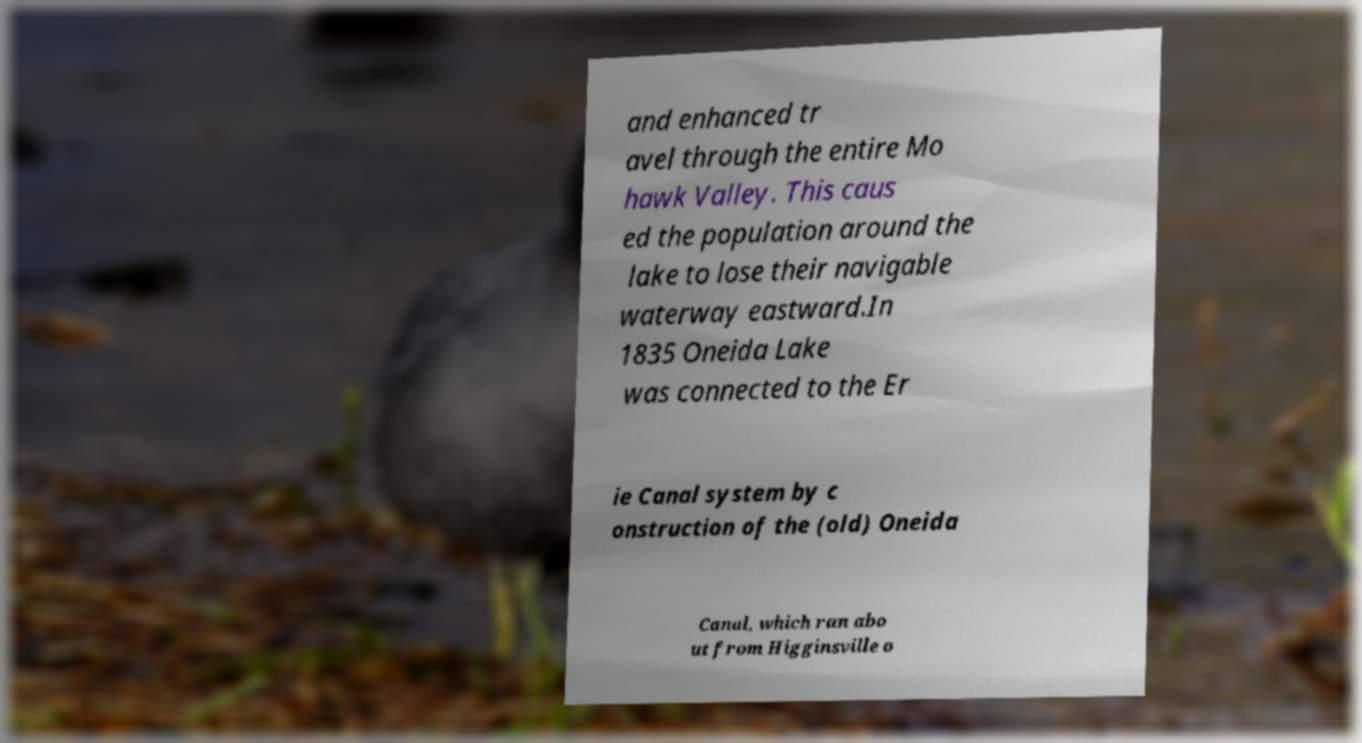Can you read and provide the text displayed in the image?This photo seems to have some interesting text. Can you extract and type it out for me? and enhanced tr avel through the entire Mo hawk Valley. This caus ed the population around the lake to lose their navigable waterway eastward.In 1835 Oneida Lake was connected to the Er ie Canal system by c onstruction of the (old) Oneida Canal, which ran abo ut from Higginsville o 